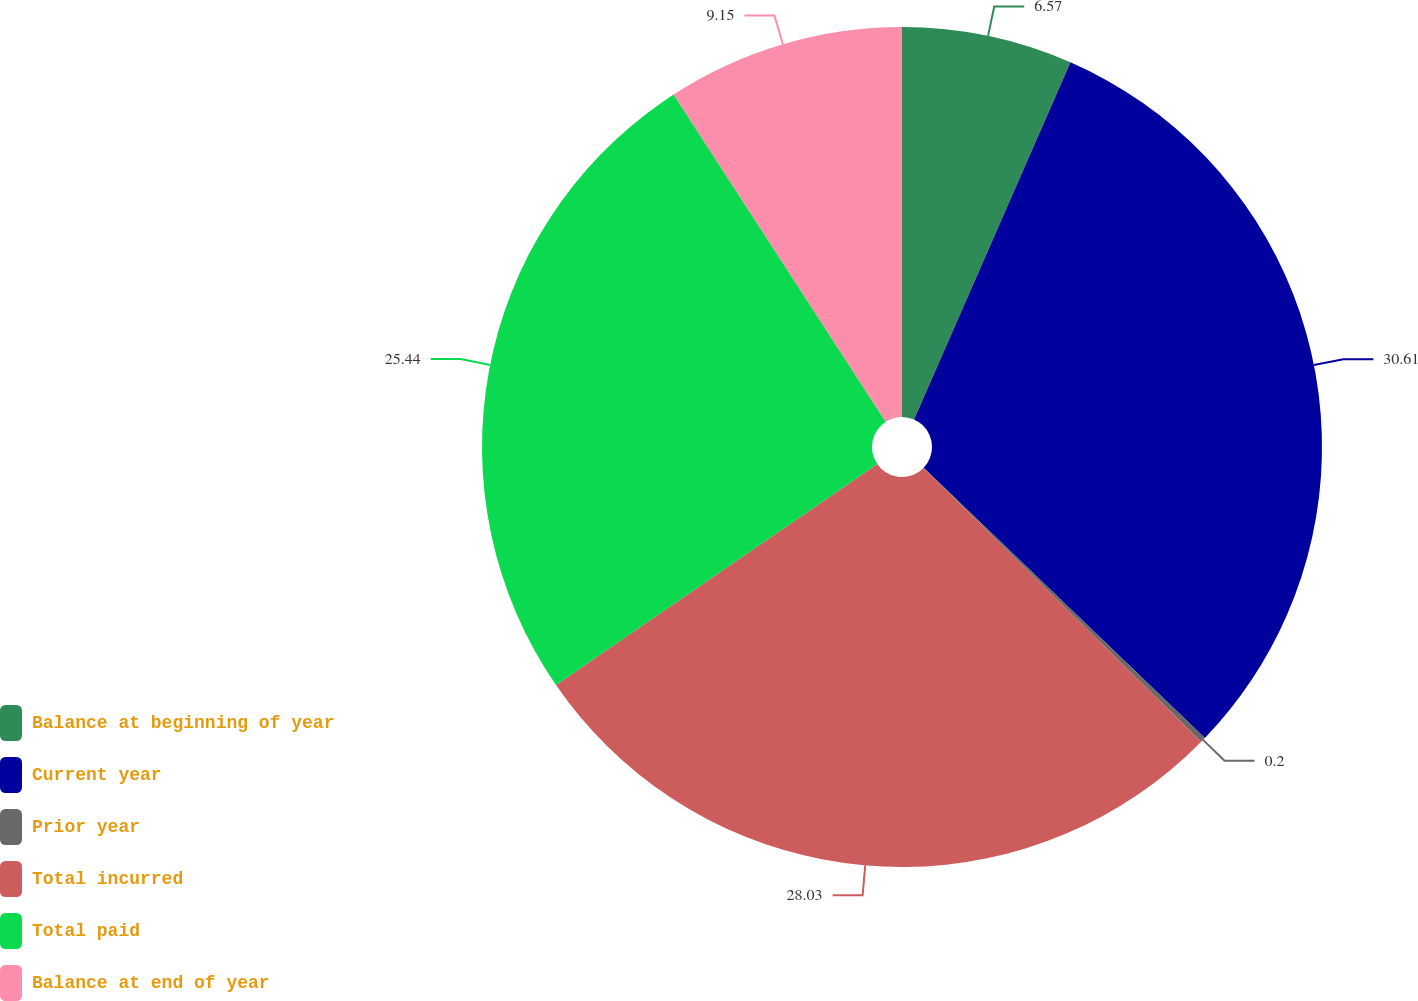Convert chart. <chart><loc_0><loc_0><loc_500><loc_500><pie_chart><fcel>Balance at beginning of year<fcel>Current year<fcel>Prior year<fcel>Total incurred<fcel>Total paid<fcel>Balance at end of year<nl><fcel>6.57%<fcel>30.61%<fcel>0.2%<fcel>28.03%<fcel>25.44%<fcel>9.15%<nl></chart> 